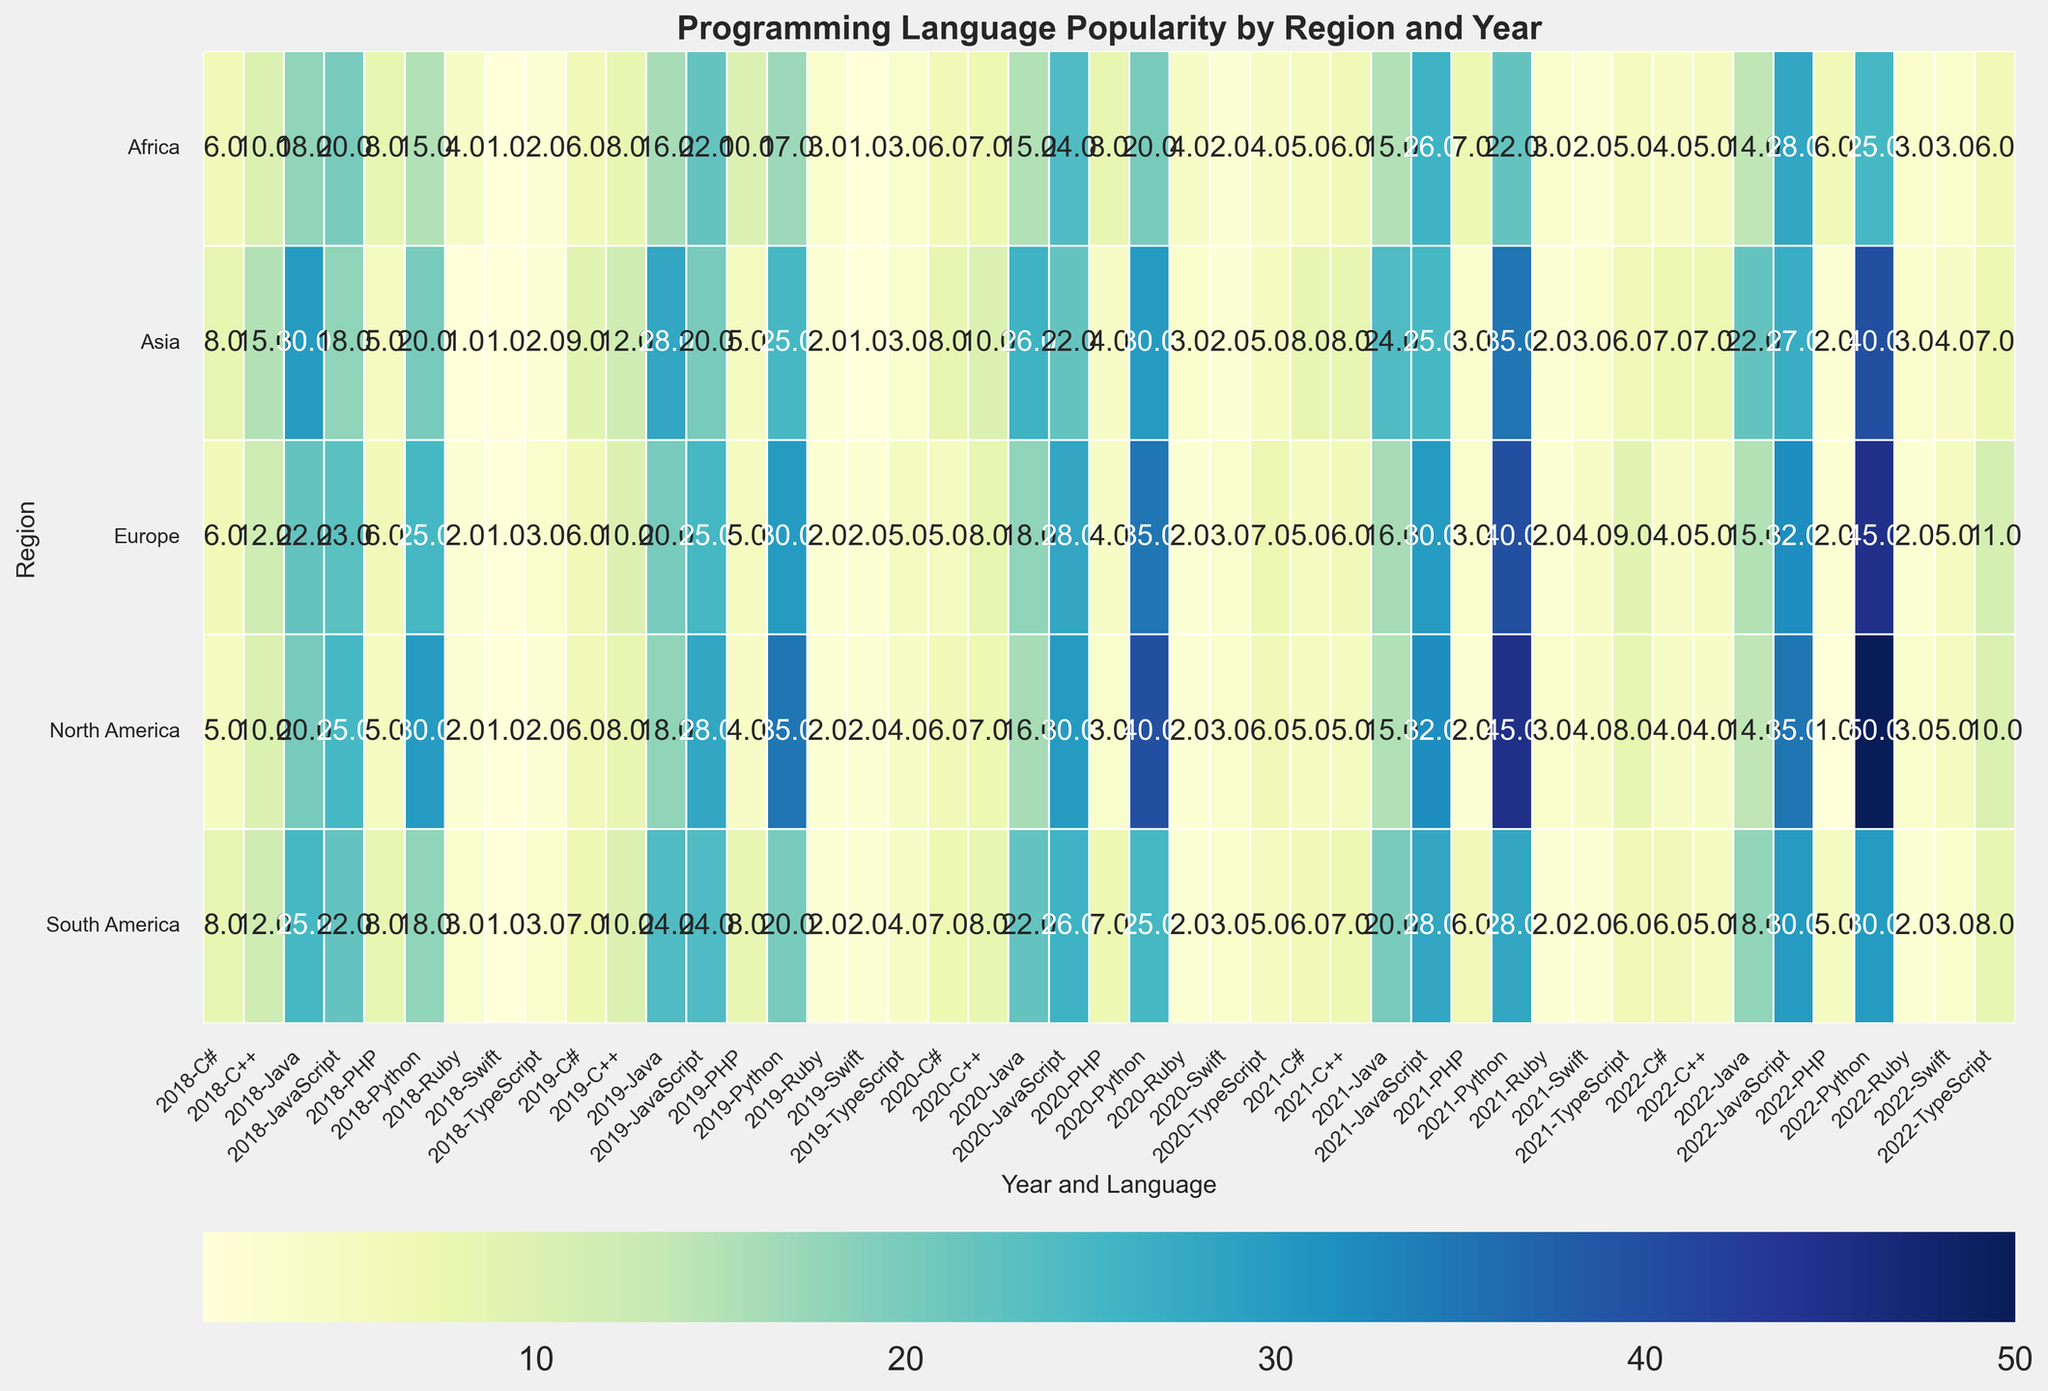What's the most popular programming language in North America in 2021? Look for the highest value in the row for North America under the year 2021. Python has the highest popularity value of 45.
Answer: Python Which year saw the highest popularity of Java in Asia? Compare the values of Java in Asia across different years. The highest value is 30 in 2018.
Answer: 2018 In which region was the popularity of C++ equal to 10 in 2020? Find the regions where C++ in 2020 is 10. Asia and Africa have popularity values of 10 for C++ in 2020.
Answer: Asia, Africa Comparing 2019 and 2022, did Python see a higher increase in popularity in North America or in Europe? Calculate the increase in popularity of Python from 2019 to 2022 in both regions. North America: 50 - 35 = 15; Europe: 45 - 30 = 15. Both regions have the same increase.
Answer: Same increase Which programming language saw a consistent rise in popularity in North America from 2018 to 2022? Check for consistent increasing values for a language in North America from 2018 to 2022. Python rises steadily: 30, 35, 40, 45, 50.
Answer: Python What is the average popularity of JavaScript in Europe over the five years (2018-2022)? Sum the popularity values for JavaScript in Europe and divide by the number of years. (23+25+28+30+32)/5 = 27.6
Answer: 27.6 By how much did the popularity of Swift increase in South America from 2018 to 2022? Subtract the 2018 value for Swift in South America from its 2022 value. 3 - 1 = 2
Answer: 2 Which region had the highest popularity of PHP in 2020? Compare the popularity values of PHP across all regions for 2020. Africa has the highest value of 8.
Answer: Africa Did TypeScript see a greater increase in popularity in Asia or North America from 2019 to 2020? Calculate the increase in popularity of TypeScript from 2019 to 2020 for both regions. Asia: 5 - 3 = 2; North America: 6 - 4 = 2. Both have the same increase.
Answer: Same increase Which two programming languages had the same popularity value in North America in 2018? Look for languages with identical popularity values in North America in 2018. C# and PHP both have a value of 5.
Answer: C#, PHP 